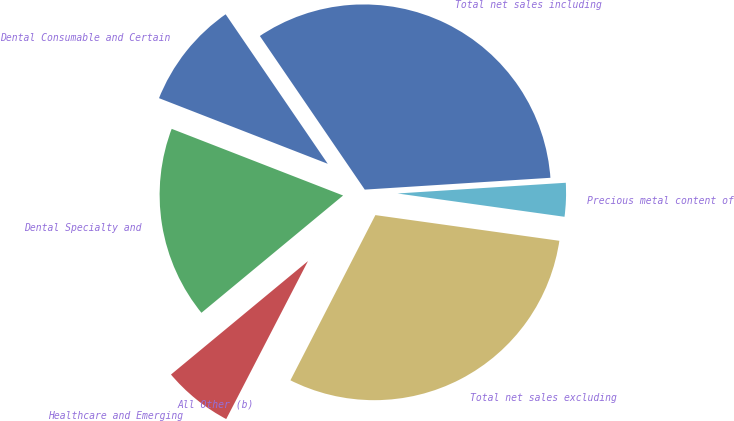Convert chart to OTSL. <chart><loc_0><loc_0><loc_500><loc_500><pie_chart><fcel>Dental Consumable and Certain<fcel>Dental Specialty and<fcel>Healthcare and Emerging<fcel>All Other (b)<fcel>Total net sales excluding<fcel>Precious metal content of<fcel>Total net sales including<nl><fcel>9.56%<fcel>16.91%<fcel>6.39%<fcel>0.04%<fcel>30.35%<fcel>3.22%<fcel>33.52%<nl></chart> 